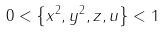<formula> <loc_0><loc_0><loc_500><loc_500>0 < \left \{ x ^ { 2 } , y ^ { 2 } , z , u \right \} < 1</formula> 